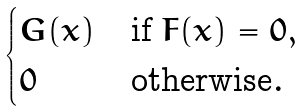<formula> <loc_0><loc_0><loc_500><loc_500>\begin{cases} G ( x ) & \text {if $F(x) = 0$} , \\ 0 & \text {otherwise} . \end{cases}</formula> 